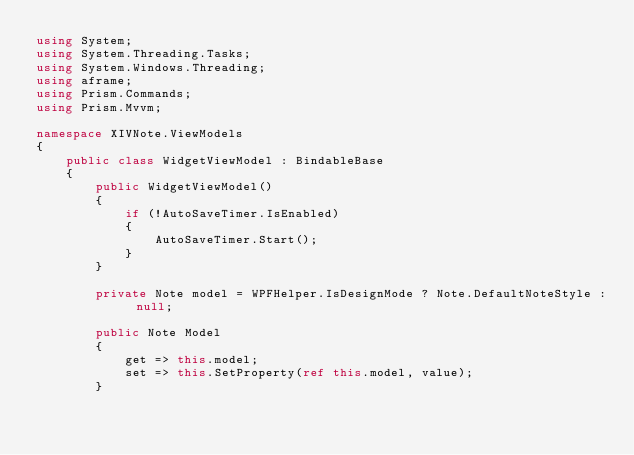<code> <loc_0><loc_0><loc_500><loc_500><_C#_>using System;
using System.Threading.Tasks;
using System.Windows.Threading;
using aframe;
using Prism.Commands;
using Prism.Mvvm;

namespace XIVNote.ViewModels
{
    public class WidgetViewModel : BindableBase
    {
        public WidgetViewModel()
        {
            if (!AutoSaveTimer.IsEnabled)
            {
                AutoSaveTimer.Start();
            }
        }

        private Note model = WPFHelper.IsDesignMode ? Note.DefaultNoteStyle : null;

        public Note Model
        {
            get => this.model;
            set => this.SetProperty(ref this.model, value);
        }
</code> 